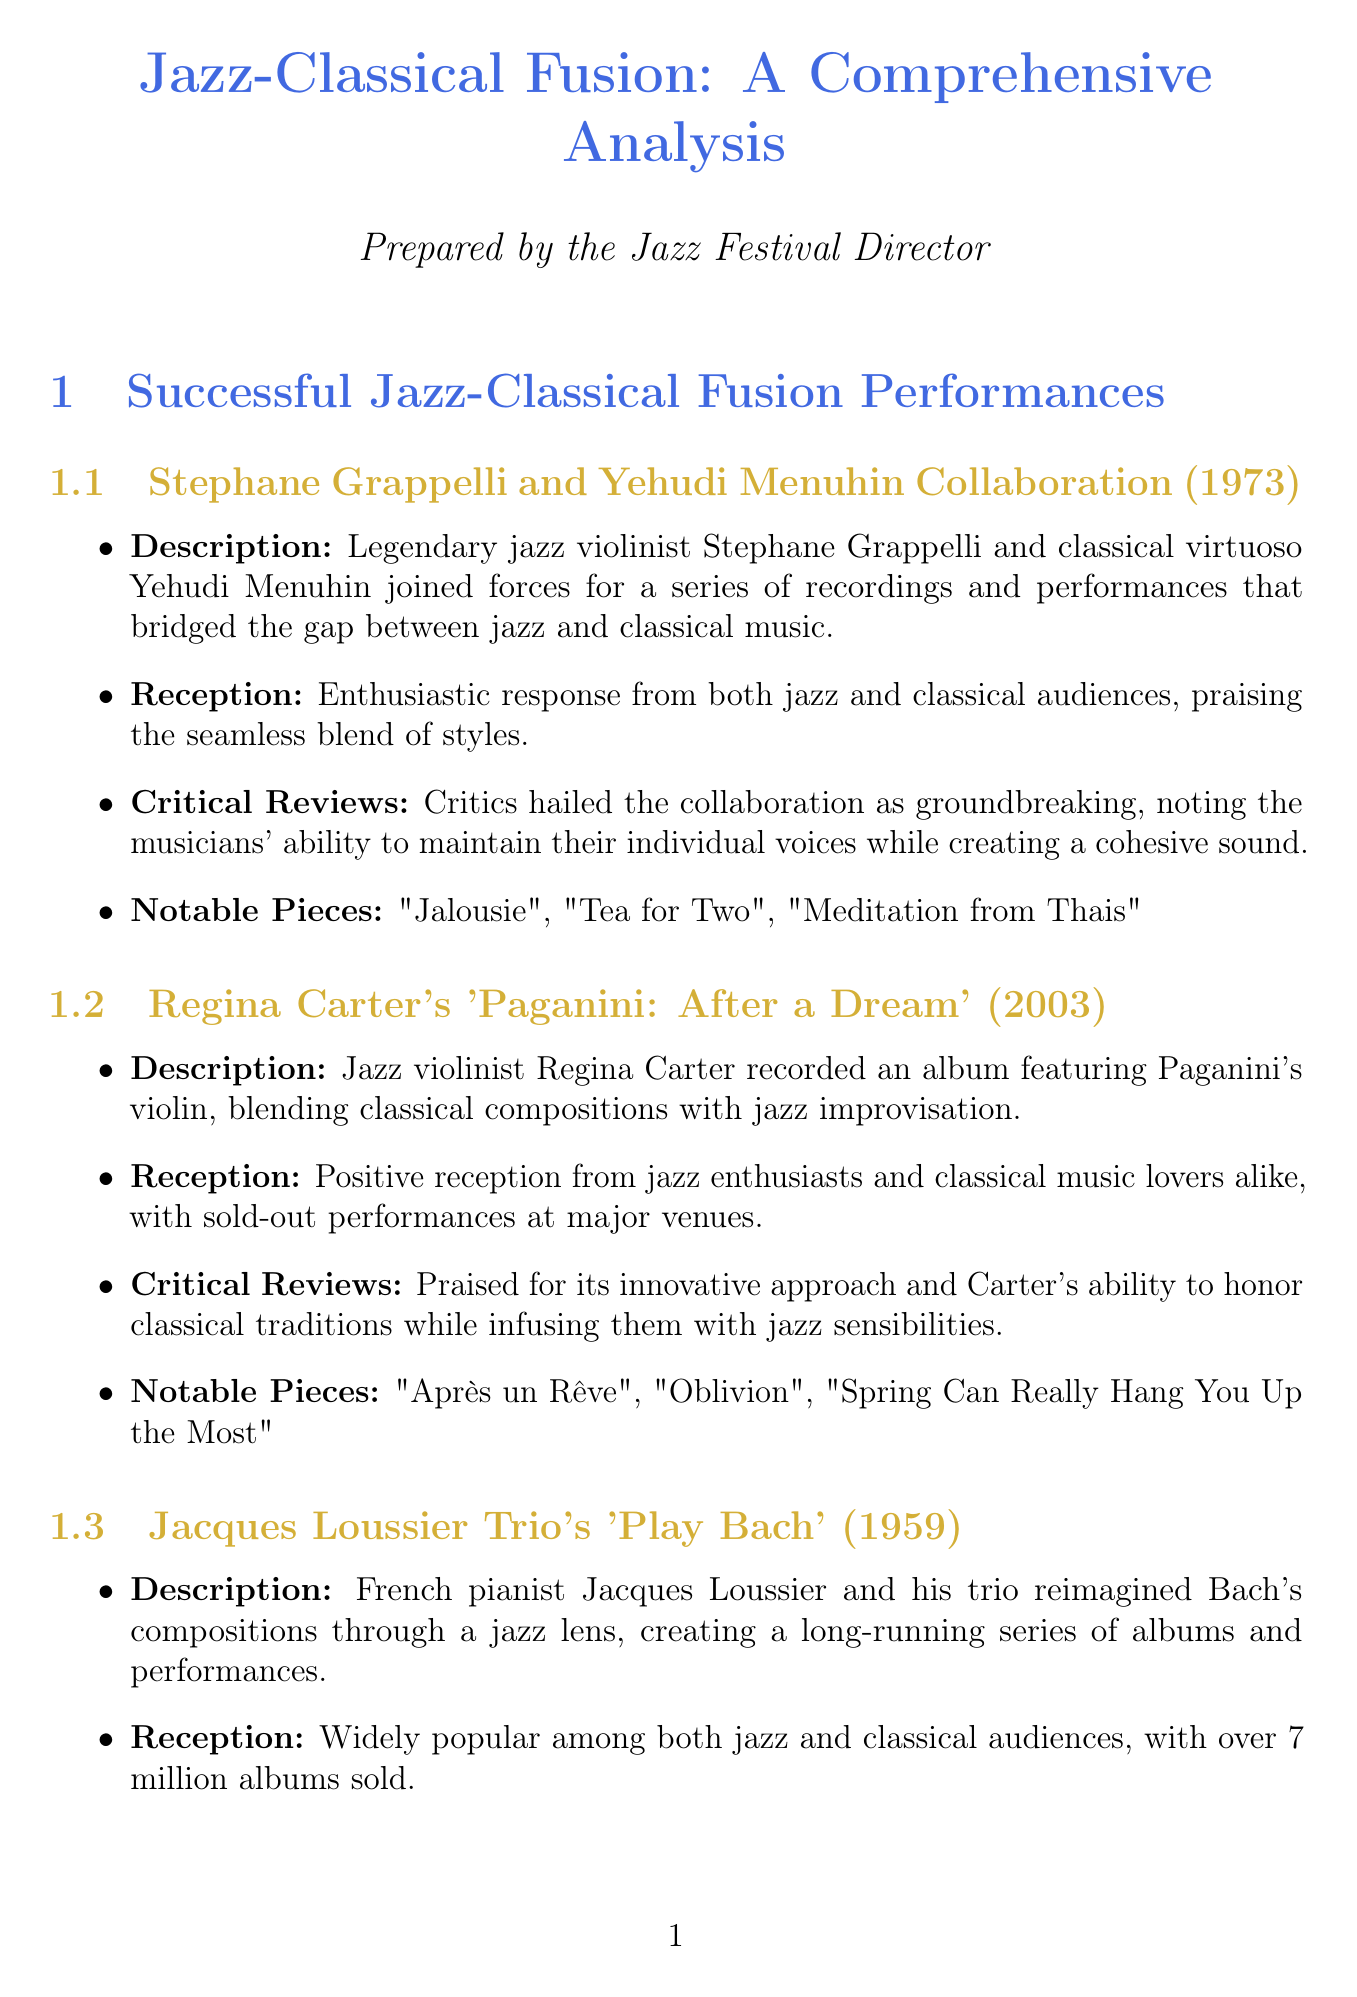What year did the Grappelli and Menuhin collaboration occur? The document states the collaboration took place in 1973.
Answer: 1973 What is the notable piece from Regina Carter's album? The document lists "Après un Rêve" as one of the notable pieces from the album.
Answer: Après un Rêve Which venue is located in New York City? The document specifies Lincoln Center as being located in New York City.
Answer: Lincoln Center What are two key elements of successful fusion performances? The document mentions several elements, including "Respect for both jazz and classical traditions" and "High level of technical proficiency in both styles."
Answer: Respect for both jazz and classical traditions, High level of technical proficiency in both styles How many albums did Jacques Loussier sell? The document states Jacques Loussier sold over 7 million albums.
Answer: Over 7 million What challenge is associated with balancing improvisation? The document cites "Balancing improvisation with structured composition" as a challenge in jazz-classical fusion.
Answer: Balancing improvisation with structured composition What is a future trend in jazz-classical fusion? The document mentions the "Incorporation of world music elements" as a future trend.
Answer: Incorporation of world music elements What is the significance of the Montreux Jazz Festival? The document highlights the festival's role in regularly featuring jazz-classical fusion performances.
Answer: Regularly features jazz-classical fusion performances What type of reception did Regina Carter's album receive? The document describes the reception as "Positive reception from jazz enthusiasts and classical music lovers alike."
Answer: Positive reception from jazz enthusiasts and classical music lovers alike 